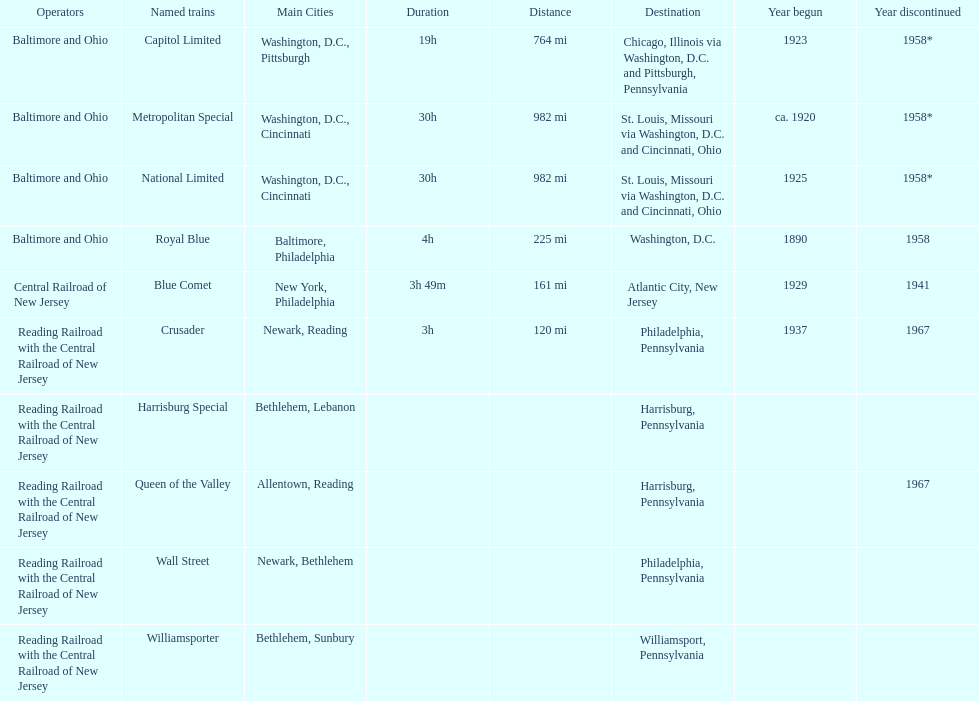What is the difference (in years) between when the royal blue began and the year the crusader began? 47. 